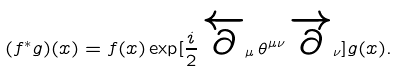Convert formula to latex. <formula><loc_0><loc_0><loc_500><loc_500>( f ^ { * } g ) ( x ) = f ( x ) \exp [ \frac { i } { 2 } \, \overleftarrow { \partial } _ { \mu } \, \theta ^ { \mu \nu } \, \overrightarrow { \partial } _ { \nu } ] g ( x ) .</formula> 